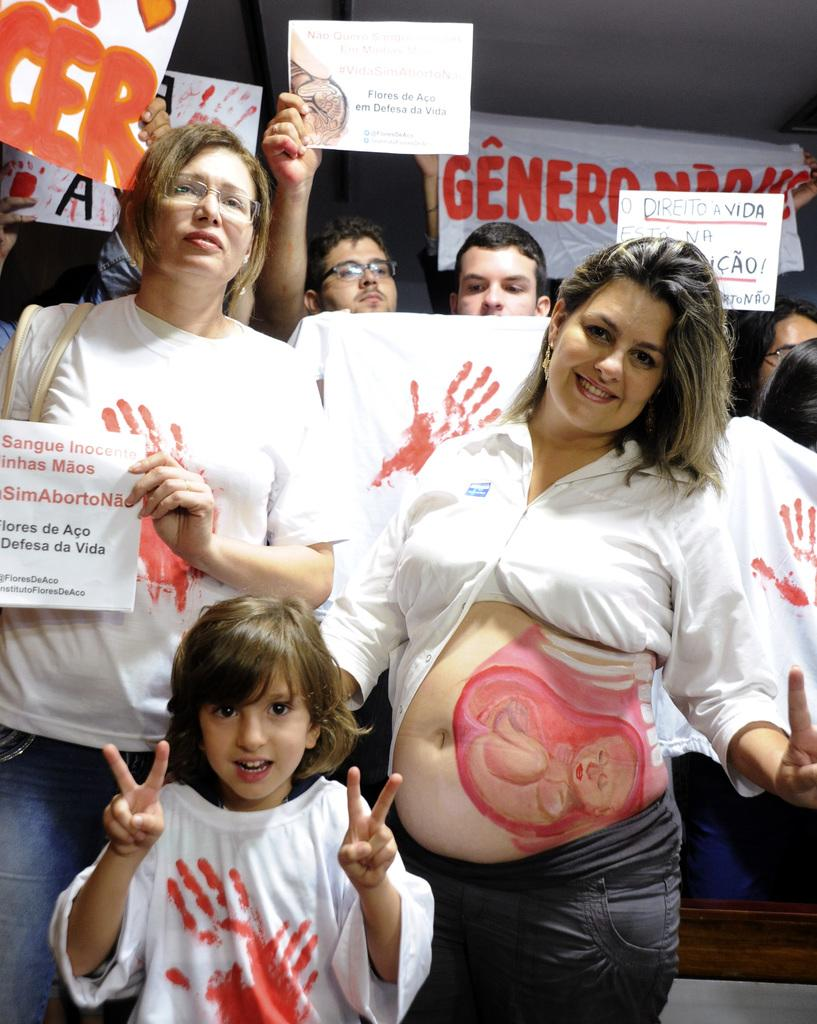Who or what can be seen in the image? There are people in the image. Can you describe any unique features of the lady in the image? The lady in the image has paintings on her stomach. What are the people behind the lady doing? These people are holding boards. How does the pollution affect the view in the image? There is no mention of pollution in the image, so it cannot be determined how it affects the view. 